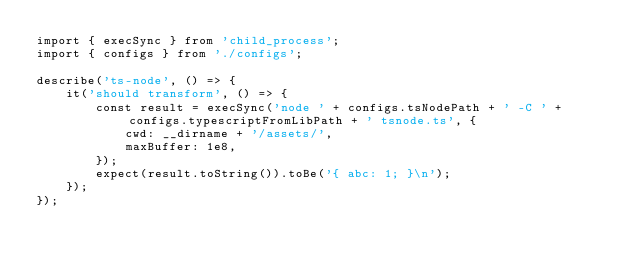Convert code to text. <code><loc_0><loc_0><loc_500><loc_500><_TypeScript_>import { execSync } from 'child_process';
import { configs } from './configs';

describe('ts-node', () => {
    it('should transform', () => {
        const result = execSync('node ' + configs.tsNodePath + ' -C ' + configs.typescriptFromLibPath + ' tsnode.ts', {
            cwd: __dirname + '/assets/',
            maxBuffer: 1e8,
        });
        expect(result.toString()).toBe('{ abc: 1; }\n');
    });
});
</code> 